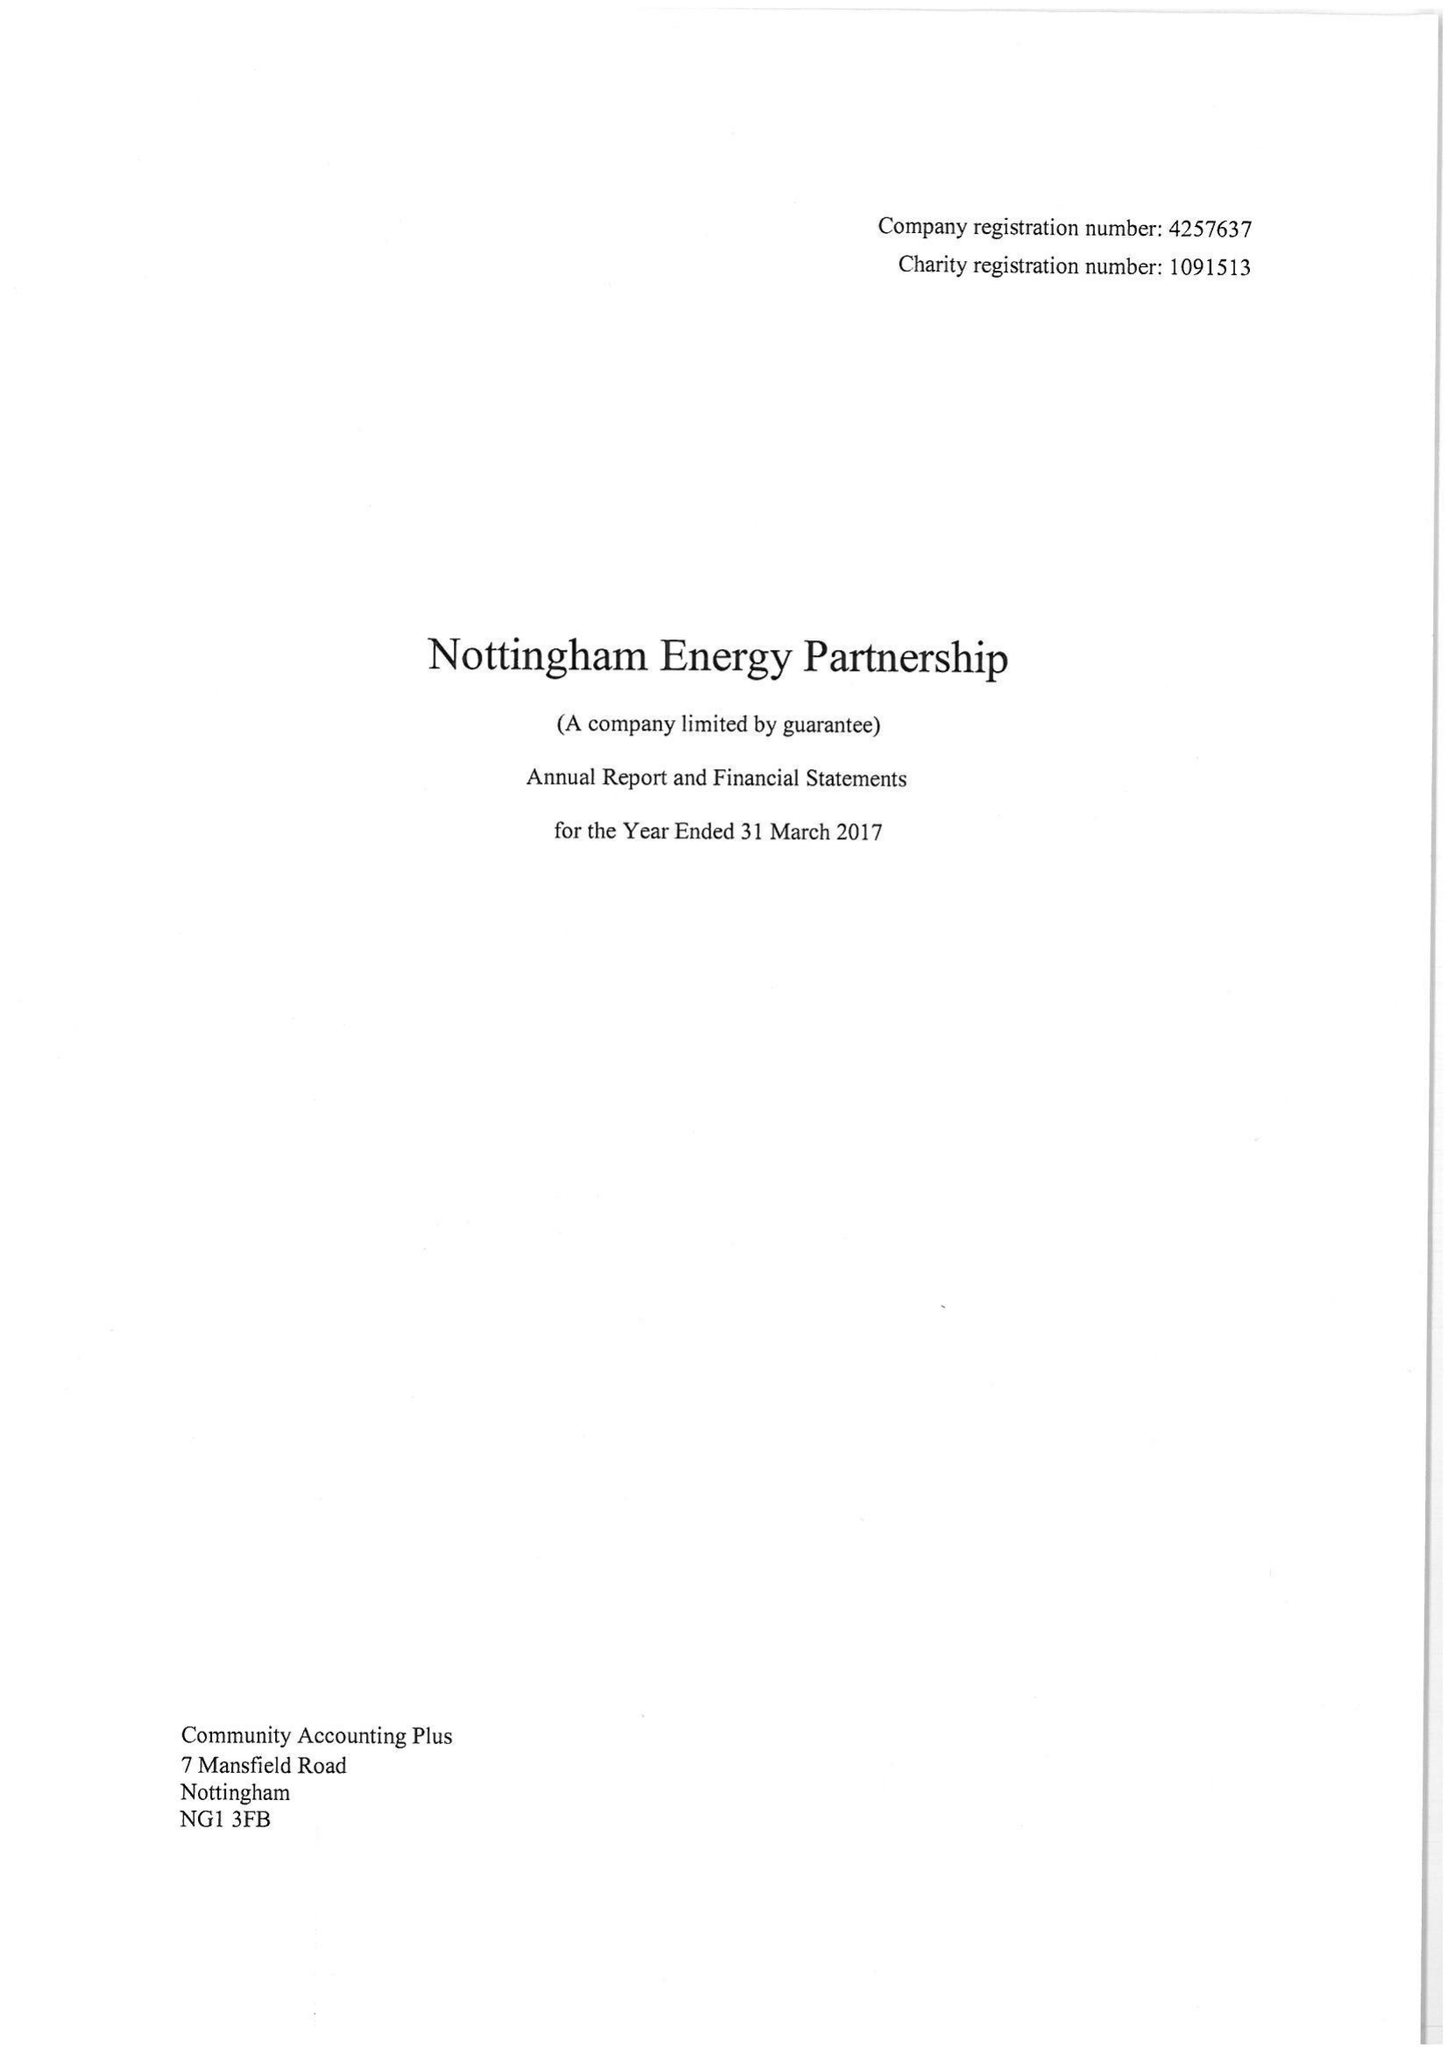What is the value for the charity_name?
Answer the question using a single word or phrase. Nottingham Energy Partnership 